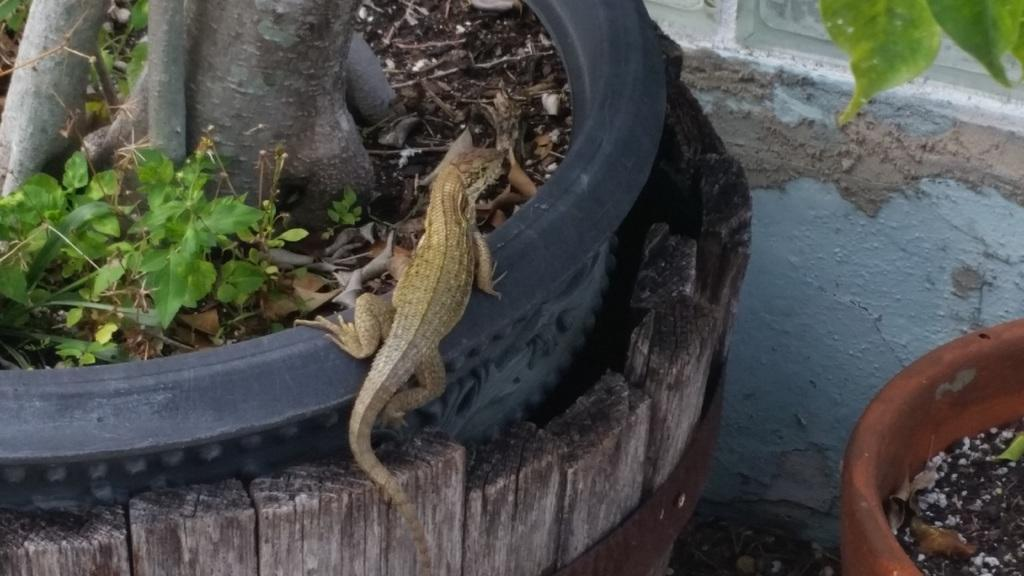What is the main subject of the image? The main subject of the image is a lizard on a pot. Can you describe the other pot in the image? There is another pot with plants in the image. What type of throne does the lizard sit on in the image? There is no throne present in the image; the lizard is sitting on a pot. How does the lizard get hot in the image? The image does not provide information about the lizard's temperature or any heat source, so we cannot determine if the lizard is hot or not. 